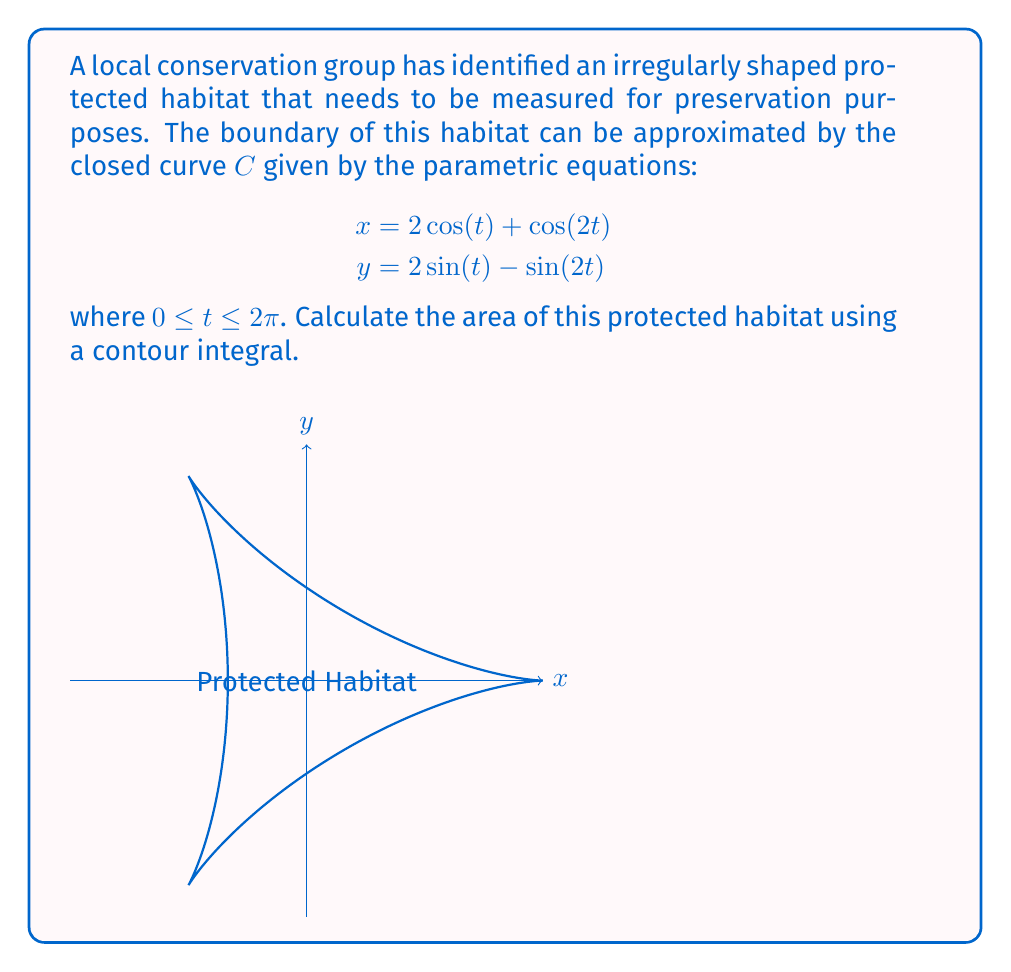Teach me how to tackle this problem. To calculate the area enclosed by this curve, we can use Green's theorem in the plane. The area $A$ of a region bounded by a simple closed curve $C$ can be computed using the contour integral:

$$A = \frac{1}{2} \oint_C (x dy - y dx)$$

Given the parametric equations:
$$x = 2\cos(t) + \cos(2t)$$
$$y = 2\sin(t) - \sin(2t)$$

We need to calculate $dx$ and $dy$:
$$dx = (-2\sin(t) - 2\sin(2t)) dt$$
$$dy = (2\cos(t) - 2\cos(2t)) dt$$

Substituting these into the contour integral:

$$\begin{align*}
A &= \frac{1}{2} \int_0^{2\pi} [(2\cos(t) + \cos(2t))(2\cos(t) - 2\cos(2t)) \\
&\quad - (2\sin(t) - \sin(2t))(-2\sin(t) - 2\sin(2t))] dt
\end{align*}$$

Expanding this expression:

$$\begin{align*}
A &= \frac{1}{2} \int_0^{2\pi} [4\cos^2(t) - 4\cos(t)\cos(2t) + 2\cos(t)\cos(2t) - 2\cos^2(2t) \\
&\quad + 4\sin^2(t) + 4\sin(t)\sin(2t) - 2\sin(t)\sin(2t) - 2\sin^2(2t)] dt
\end{align*}$$

Simplifying and using trigonometric identities:

$$\begin{align*}
A &= \frac{1}{2} \int_0^{2\pi} [4\cos^2(t) + 4\sin^2(t) - 2\cos(t)\cos(2t) + 2\sin(t)\sin(2t) \\
&\quad - 2\cos^2(2t) - 2\sin^2(2t)] dt \\
&= \frac{1}{2} \int_0^{2\pi} [4 - 2\cos(3t) - 2] dt \\
&= \int_0^{2\pi} [1 - \cos(3t)] dt
\end{align*}$$

Evaluating this integral:

$$\begin{align*}
A &= [t - \frac{1}{3}\sin(3t)]_0^{2\pi} \\
&= 2\pi - 0 - (0 - 0) \\
&= 2\pi
\end{align*}$$

Therefore, the area of the protected habitat is $2\pi$ square units.
Answer: The area of the irregularly shaped protected habitat is $2\pi$ square units. 